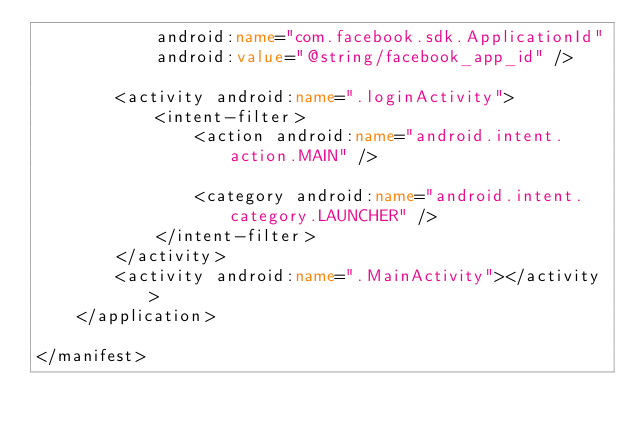<code> <loc_0><loc_0><loc_500><loc_500><_XML_>            android:name="com.facebook.sdk.ApplicationId"
            android:value="@string/facebook_app_id" />

        <activity android:name=".loginActivity">
            <intent-filter>
                <action android:name="android.intent.action.MAIN" />

                <category android:name="android.intent.category.LAUNCHER" />
            </intent-filter>
        </activity>
        <activity android:name=".MainActivity"></activity>
    </application>

</manifest></code> 